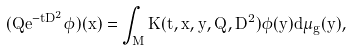Convert formula to latex. <formula><loc_0><loc_0><loc_500><loc_500>( Q e ^ { - t D ^ { 2 } } \phi ) ( x ) = \int _ { M } K ( t , x , y , Q , D ^ { 2 } ) \phi ( y ) d \mu _ { g } ( y ) ,</formula> 